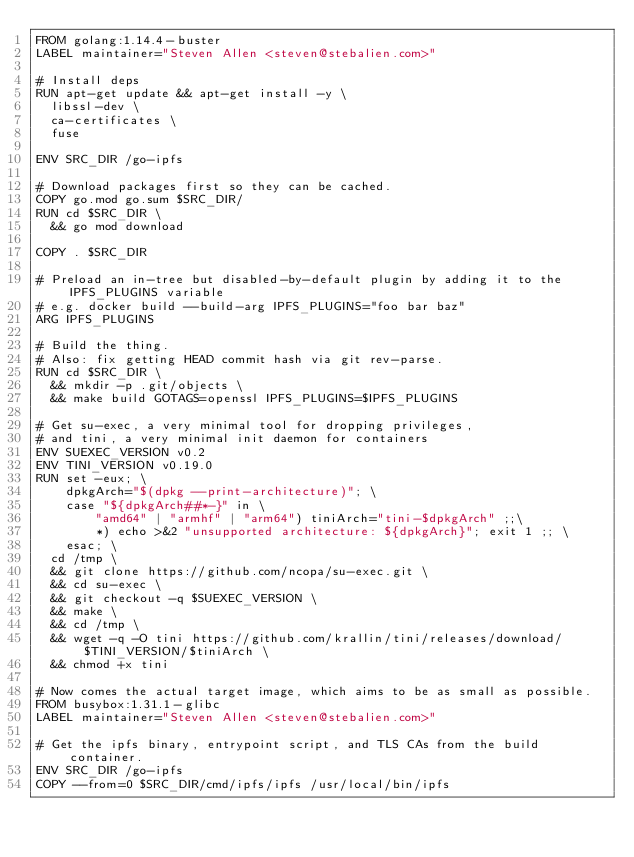<code> <loc_0><loc_0><loc_500><loc_500><_Dockerfile_>FROM golang:1.14.4-buster
LABEL maintainer="Steven Allen <steven@stebalien.com>"

# Install deps
RUN apt-get update && apt-get install -y \
  libssl-dev \
  ca-certificates \
  fuse

ENV SRC_DIR /go-ipfs

# Download packages first so they can be cached.
COPY go.mod go.sum $SRC_DIR/
RUN cd $SRC_DIR \
  && go mod download

COPY . $SRC_DIR

# Preload an in-tree but disabled-by-default plugin by adding it to the IPFS_PLUGINS variable
# e.g. docker build --build-arg IPFS_PLUGINS="foo bar baz"
ARG IPFS_PLUGINS

# Build the thing.
# Also: fix getting HEAD commit hash via git rev-parse.
RUN cd $SRC_DIR \
  && mkdir -p .git/objects \
  && make build GOTAGS=openssl IPFS_PLUGINS=$IPFS_PLUGINS

# Get su-exec, a very minimal tool for dropping privileges,
# and tini, a very minimal init daemon for containers
ENV SUEXEC_VERSION v0.2
ENV TINI_VERSION v0.19.0
RUN set -eux; \
    dpkgArch="$(dpkg --print-architecture)"; \
    case "${dpkgArch##*-}" in \
        "amd64" | "armhf" | "arm64") tiniArch="tini-$dpkgArch" ;;\
        *) echo >&2 "unsupported architecture: ${dpkgArch}"; exit 1 ;; \
    esac; \
  cd /tmp \
  && git clone https://github.com/ncopa/su-exec.git \
  && cd su-exec \
  && git checkout -q $SUEXEC_VERSION \
  && make \
  && cd /tmp \
  && wget -q -O tini https://github.com/krallin/tini/releases/download/$TINI_VERSION/$tiniArch \
  && chmod +x tini

# Now comes the actual target image, which aims to be as small as possible.
FROM busybox:1.31.1-glibc
LABEL maintainer="Steven Allen <steven@stebalien.com>"

# Get the ipfs binary, entrypoint script, and TLS CAs from the build container.
ENV SRC_DIR /go-ipfs
COPY --from=0 $SRC_DIR/cmd/ipfs/ipfs /usr/local/bin/ipfs</code> 